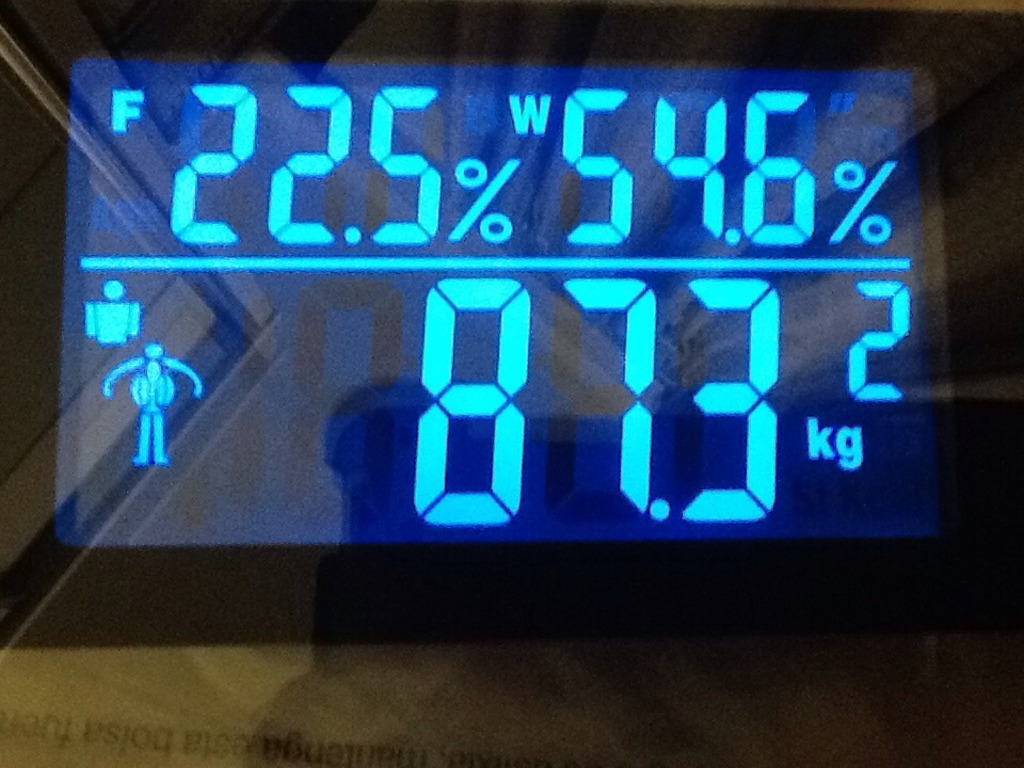Can you explain what the different percentage values mean? Certainly! The body fat percentage, shown as 22.5%, indicates the proportion of a person's mass that consists of fat tissue compared to lean tissue. The 54.6% indicates the water percentage, showing how much of the body's weight is due to fluids. This is crucial for assessing hydration levels and overall water balance in the body. 